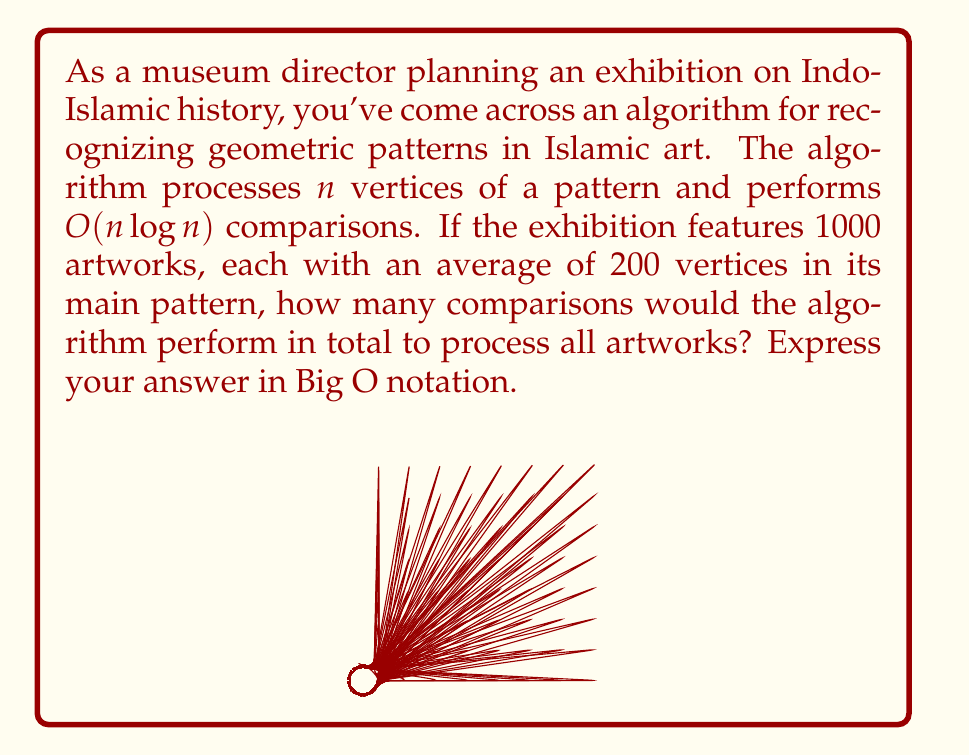Can you solve this math problem? Let's approach this step-by-step:

1) First, we need to understand what the question is asking:
   - We have 1000 artworks
   - Each artwork has an average of 200 vertices in its main pattern
   - The algorithm performs $O(n \log n)$ comparisons for $n$ vertices

2) For a single artwork with 200 vertices, the number of comparisons is:
   $O(200 \log 200)$

3) We need to do this for all 1000 artworks. In Big O notation, we multiply the number of operations:
   $1000 * O(200 \log 200)$

4) In Big O notation, we can simplify constant factors:
   $O(200000 \log 200)$

5) The logarithm of a constant is also a constant in Big O notation:
   $O(200000 * constant)$

6) Constants can be removed in Big O notation:
   $O(200000)$

7) In Big O notation, we typically express numbers in scientific notation:
   $O(2 * 10^5)$

8) Finally, in Big O notation, we remove constant factors:
   $O(10^5)$

This represents the upper bound of the number of comparisons the algorithm will perform for all artworks in the exhibition.
Answer: $O(10^5)$ 